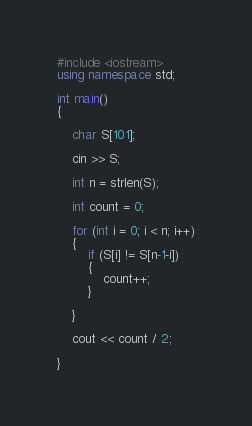Convert code to text. <code><loc_0><loc_0><loc_500><loc_500><_C++_>#include <iostream>
using namespace std;

int main()
{
	
	char S[101];

	cin >> S;

	int n = strlen(S);

	int count = 0;

	for (int i = 0; i < n; i++)
	{
		if (S[i] != S[n-1-i])
		{
			count++;
		}

	}

	cout << count / 2;

}</code> 